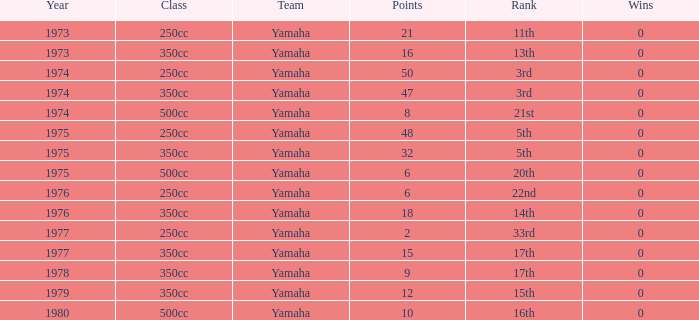Which Wins have a Class of 500cc, and a Year smaller than 1975? 0.0. 